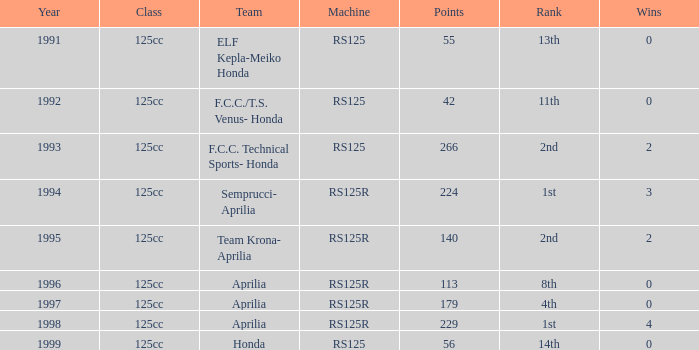Which 1st-ranked team used an rs125r machine in a year later than 1995? Aprilia. Would you be able to parse every entry in this table? {'header': ['Year', 'Class', 'Team', 'Machine', 'Points', 'Rank', 'Wins'], 'rows': [['1991', '125cc', 'ELF Kepla-Meiko Honda', 'RS125', '55', '13th', '0'], ['1992', '125cc', 'F.C.C./T.S. Venus- Honda', 'RS125', '42', '11th', '0'], ['1993', '125cc', 'F.C.C. Technical Sports- Honda', 'RS125', '266', '2nd', '2'], ['1994', '125cc', 'Semprucci- Aprilia', 'RS125R', '224', '1st', '3'], ['1995', '125cc', 'Team Krona- Aprilia', 'RS125R', '140', '2nd', '2'], ['1996', '125cc', 'Aprilia', 'RS125R', '113', '8th', '0'], ['1997', '125cc', 'Aprilia', 'RS125R', '179', '4th', '0'], ['1998', '125cc', 'Aprilia', 'RS125R', '229', '1st', '4'], ['1999', '125cc', 'Honda', 'RS125', '56', '14th', '0']]} 